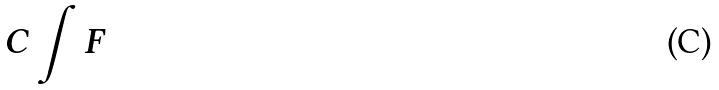Convert formula to latex. <formula><loc_0><loc_0><loc_500><loc_500>C \int F</formula> 